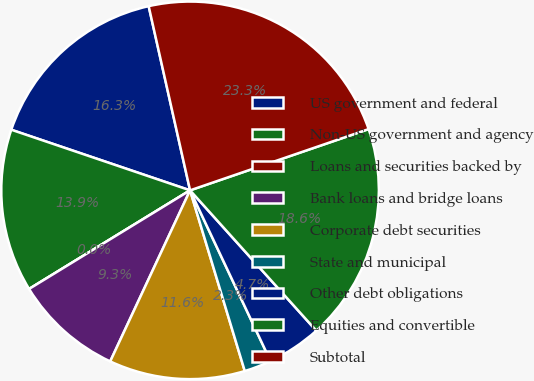Convert chart. <chart><loc_0><loc_0><loc_500><loc_500><pie_chart><fcel>US government and federal<fcel>Non-US government and agency<fcel>Loans and securities backed by<fcel>Bank loans and bridge loans<fcel>Corporate debt securities<fcel>State and municipal<fcel>Other debt obligations<fcel>Equities and convertible<fcel>Subtotal<nl><fcel>16.28%<fcel>13.95%<fcel>0.0%<fcel>9.3%<fcel>11.63%<fcel>2.33%<fcel>4.65%<fcel>18.6%<fcel>23.26%<nl></chart> 